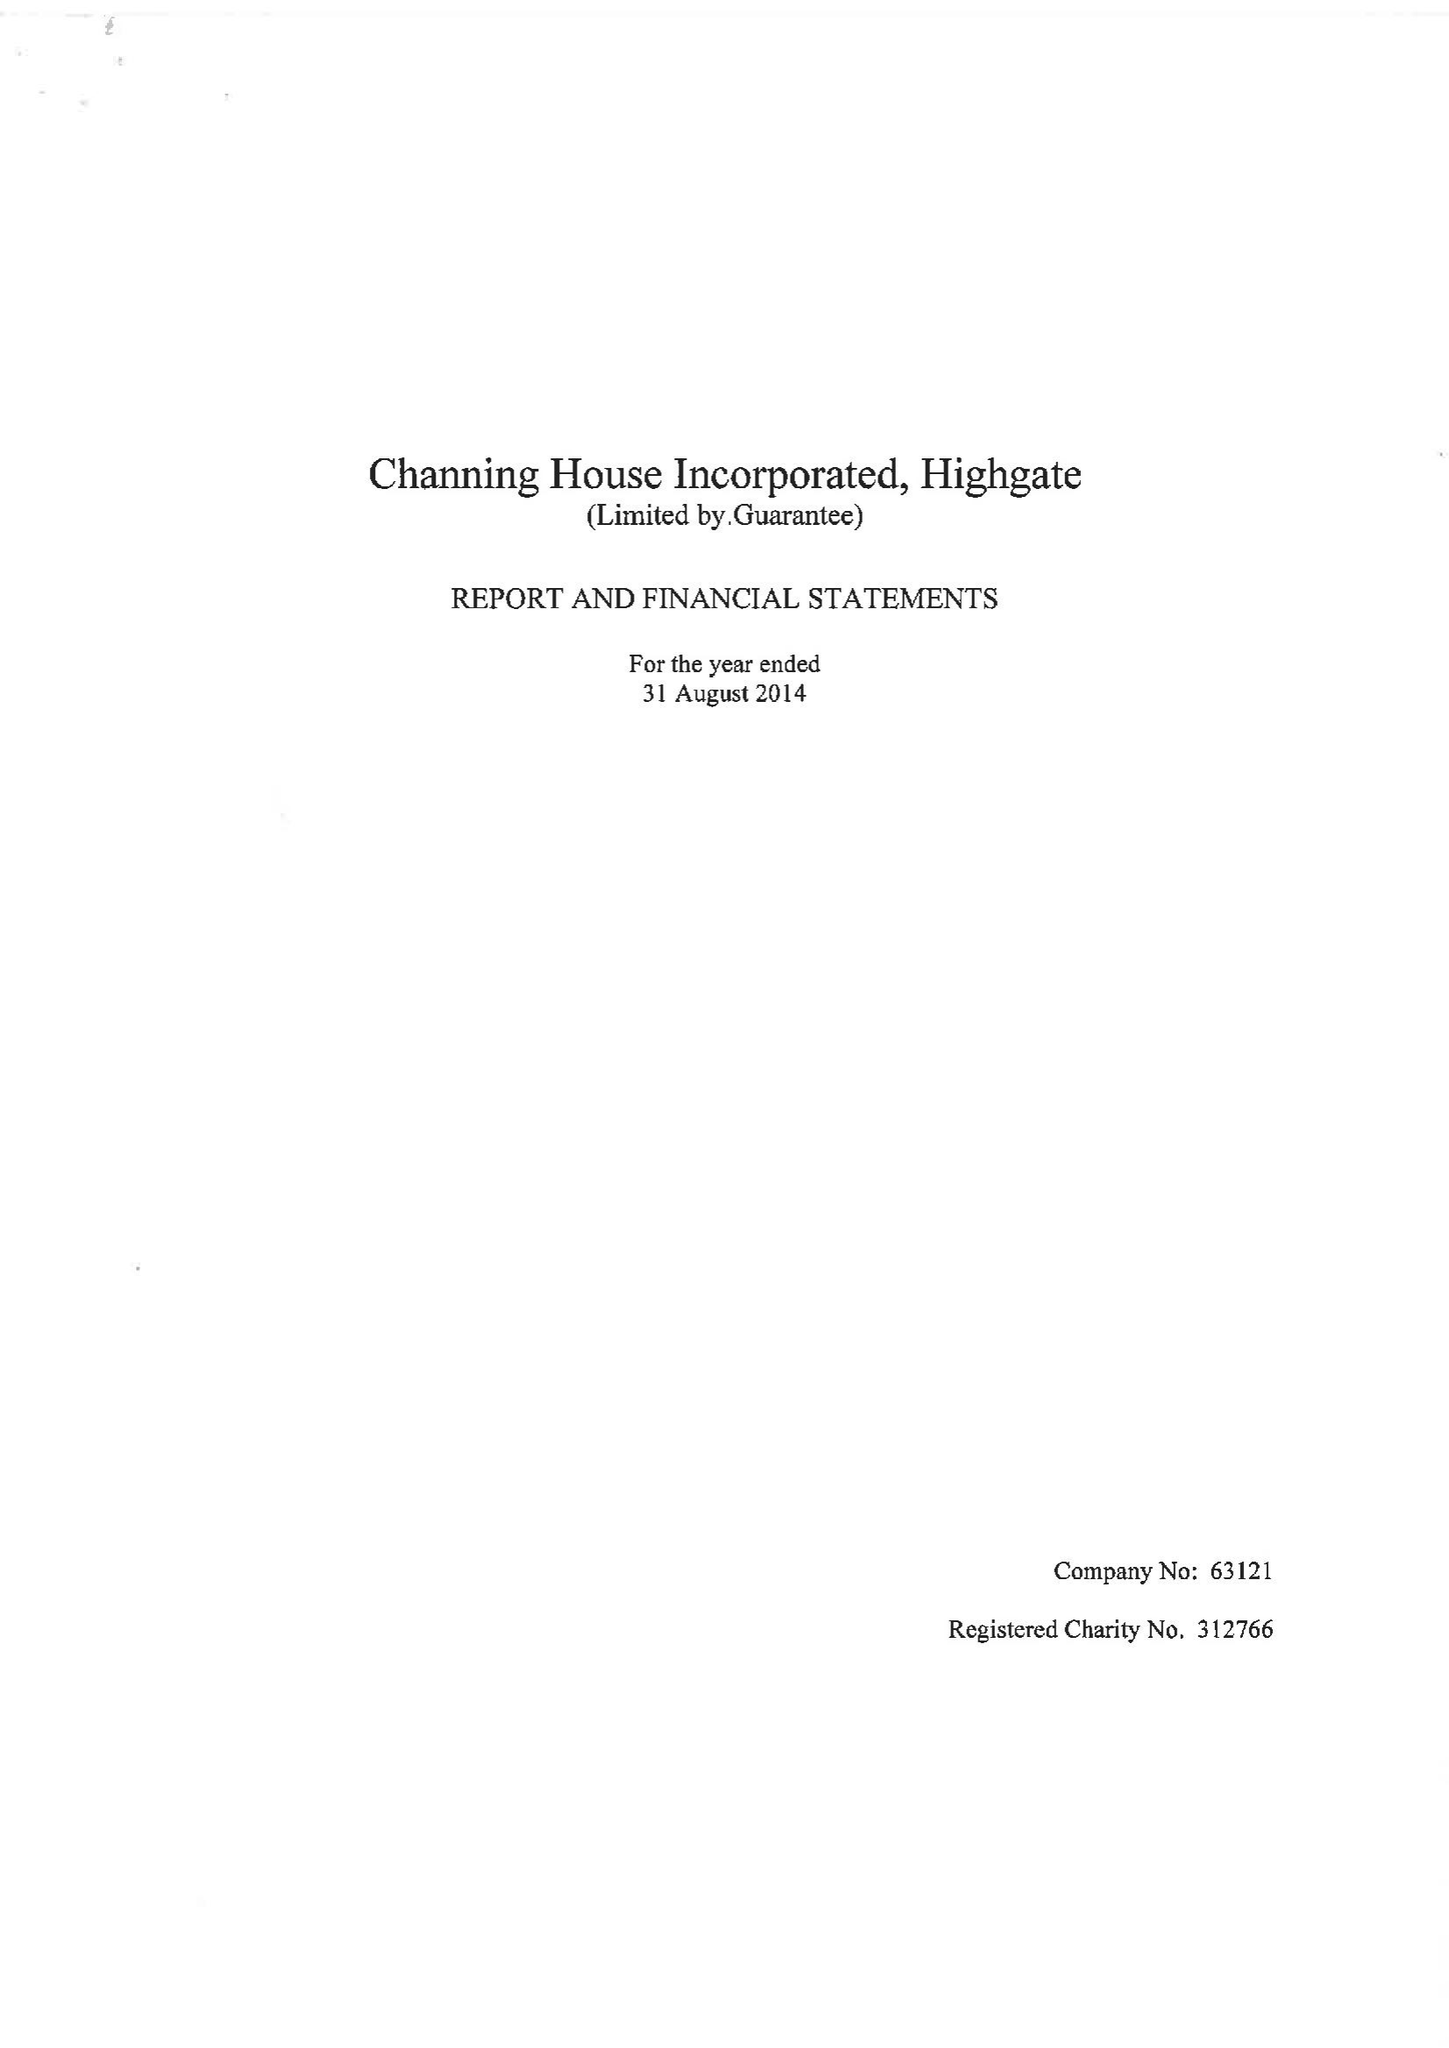What is the value for the charity_number?
Answer the question using a single word or phrase. 312766 